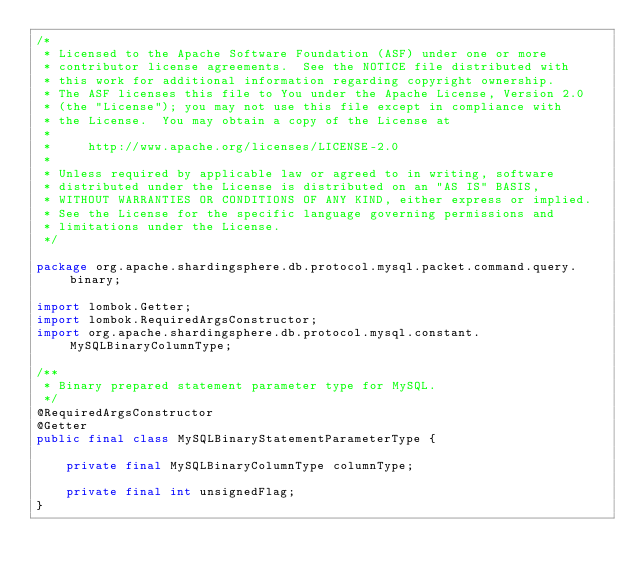<code> <loc_0><loc_0><loc_500><loc_500><_Java_>/*
 * Licensed to the Apache Software Foundation (ASF) under one or more
 * contributor license agreements.  See the NOTICE file distributed with
 * this work for additional information regarding copyright ownership.
 * The ASF licenses this file to You under the Apache License, Version 2.0
 * (the "License"); you may not use this file except in compliance with
 * the License.  You may obtain a copy of the License at
 *
 *     http://www.apache.org/licenses/LICENSE-2.0
 *
 * Unless required by applicable law or agreed to in writing, software
 * distributed under the License is distributed on an "AS IS" BASIS,
 * WITHOUT WARRANTIES OR CONDITIONS OF ANY KIND, either express or implied.
 * See the License for the specific language governing permissions and
 * limitations under the License.
 */

package org.apache.shardingsphere.db.protocol.mysql.packet.command.query.binary;

import lombok.Getter;
import lombok.RequiredArgsConstructor;
import org.apache.shardingsphere.db.protocol.mysql.constant.MySQLBinaryColumnType;

/**
 * Binary prepared statement parameter type for MySQL.
 */
@RequiredArgsConstructor
@Getter
public final class MySQLBinaryStatementParameterType {
    
    private final MySQLBinaryColumnType columnType;
    
    private final int unsignedFlag;
}
</code> 